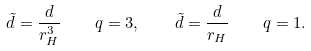Convert formula to latex. <formula><loc_0><loc_0><loc_500><loc_500>\tilde { d } = \frac { d } { r _ { H } ^ { 3 } } \quad q = 3 , \quad \tilde { d } = \frac { d } { r _ { H } } \quad q = 1 .</formula> 